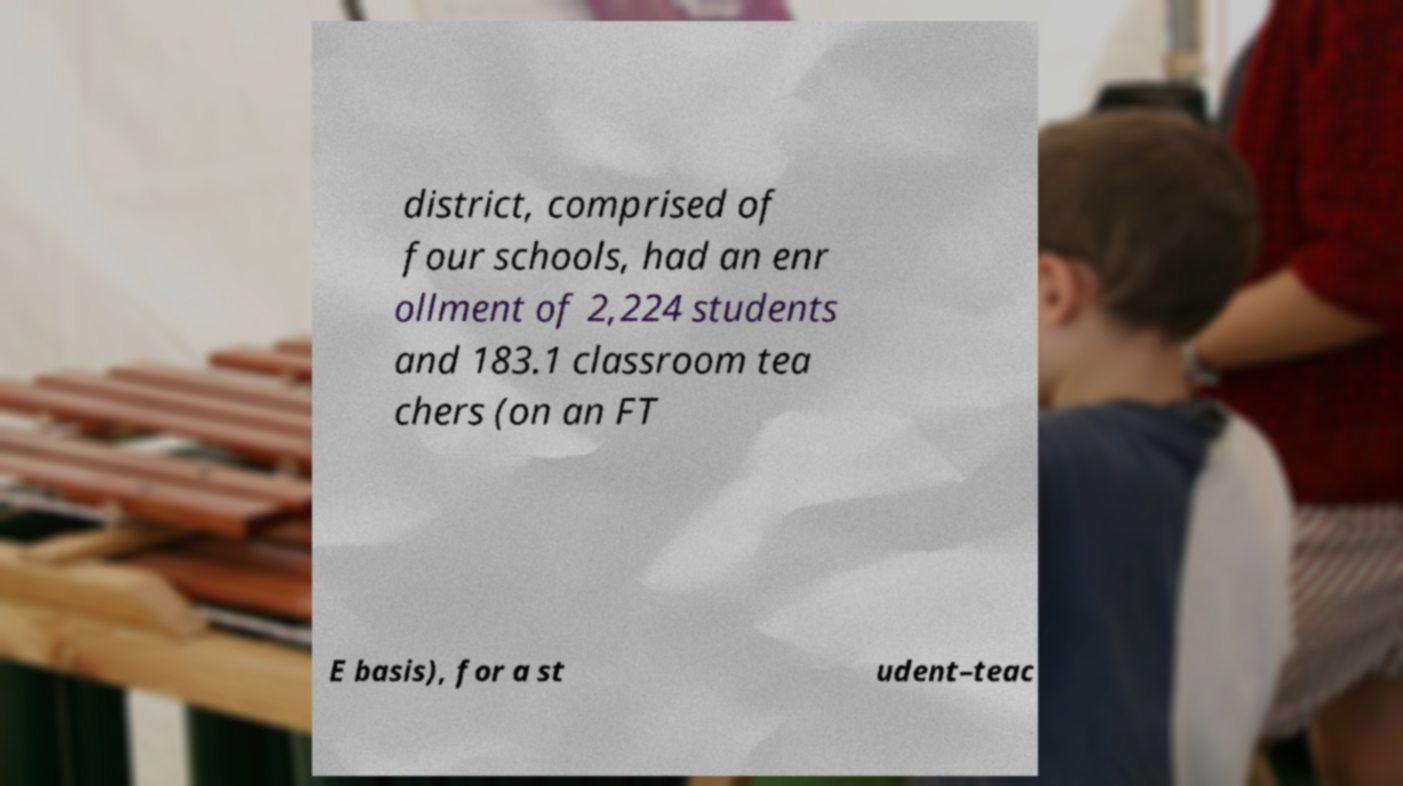I need the written content from this picture converted into text. Can you do that? district, comprised of four schools, had an enr ollment of 2,224 students and 183.1 classroom tea chers (on an FT E basis), for a st udent–teac 